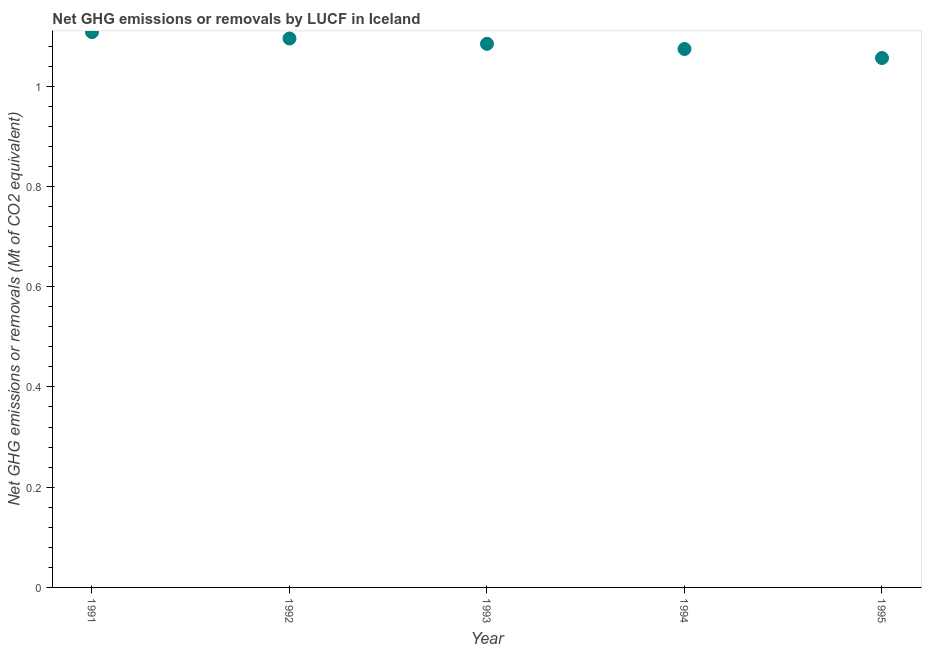What is the ghg net emissions or removals in 1992?
Provide a short and direct response. 1.1. Across all years, what is the maximum ghg net emissions or removals?
Give a very brief answer. 1.11. Across all years, what is the minimum ghg net emissions or removals?
Offer a very short reply. 1.06. What is the sum of the ghg net emissions or removals?
Provide a succinct answer. 5.42. What is the difference between the ghg net emissions or removals in 1992 and 1995?
Offer a very short reply. 0.04. What is the average ghg net emissions or removals per year?
Make the answer very short. 1.08. What is the median ghg net emissions or removals?
Make the answer very short. 1.08. In how many years, is the ghg net emissions or removals greater than 0.92 Mt?
Your response must be concise. 5. Do a majority of the years between 1992 and 1995 (inclusive) have ghg net emissions or removals greater than 0.24000000000000002 Mt?
Provide a short and direct response. Yes. What is the ratio of the ghg net emissions or removals in 1991 to that in 1993?
Keep it short and to the point. 1.02. Is the ghg net emissions or removals in 1991 less than that in 1995?
Provide a short and direct response. No. Is the difference between the ghg net emissions or removals in 1992 and 1994 greater than the difference between any two years?
Your answer should be very brief. No. What is the difference between the highest and the second highest ghg net emissions or removals?
Give a very brief answer. 0.01. Is the sum of the ghg net emissions or removals in 1991 and 1992 greater than the maximum ghg net emissions or removals across all years?
Provide a succinct answer. Yes. What is the difference between the highest and the lowest ghg net emissions or removals?
Ensure brevity in your answer.  0.05. In how many years, is the ghg net emissions or removals greater than the average ghg net emissions or removals taken over all years?
Provide a short and direct response. 3. Does the ghg net emissions or removals monotonically increase over the years?
Keep it short and to the point. No. What is the difference between two consecutive major ticks on the Y-axis?
Your answer should be very brief. 0.2. Does the graph contain grids?
Your answer should be compact. No. What is the title of the graph?
Your response must be concise. Net GHG emissions or removals by LUCF in Iceland. What is the label or title of the Y-axis?
Keep it short and to the point. Net GHG emissions or removals (Mt of CO2 equivalent). What is the Net GHG emissions or removals (Mt of CO2 equivalent) in 1991?
Ensure brevity in your answer.  1.11. What is the Net GHG emissions or removals (Mt of CO2 equivalent) in 1992?
Offer a terse response. 1.1. What is the Net GHG emissions or removals (Mt of CO2 equivalent) in 1993?
Offer a terse response. 1.08. What is the Net GHG emissions or removals (Mt of CO2 equivalent) in 1994?
Your answer should be very brief. 1.07. What is the Net GHG emissions or removals (Mt of CO2 equivalent) in 1995?
Offer a very short reply. 1.06. What is the difference between the Net GHG emissions or removals (Mt of CO2 equivalent) in 1991 and 1992?
Offer a terse response. 0.01. What is the difference between the Net GHG emissions or removals (Mt of CO2 equivalent) in 1991 and 1993?
Your response must be concise. 0.02. What is the difference between the Net GHG emissions or removals (Mt of CO2 equivalent) in 1991 and 1994?
Make the answer very short. 0.03. What is the difference between the Net GHG emissions or removals (Mt of CO2 equivalent) in 1991 and 1995?
Ensure brevity in your answer.  0.05. What is the difference between the Net GHG emissions or removals (Mt of CO2 equivalent) in 1992 and 1993?
Make the answer very short. 0.01. What is the difference between the Net GHG emissions or removals (Mt of CO2 equivalent) in 1992 and 1994?
Your response must be concise. 0.02. What is the difference between the Net GHG emissions or removals (Mt of CO2 equivalent) in 1992 and 1995?
Your response must be concise. 0.04. What is the difference between the Net GHG emissions or removals (Mt of CO2 equivalent) in 1993 and 1994?
Provide a short and direct response. 0.01. What is the difference between the Net GHG emissions or removals (Mt of CO2 equivalent) in 1993 and 1995?
Your response must be concise. 0.03. What is the difference between the Net GHG emissions or removals (Mt of CO2 equivalent) in 1994 and 1995?
Your response must be concise. 0.02. What is the ratio of the Net GHG emissions or removals (Mt of CO2 equivalent) in 1991 to that in 1992?
Keep it short and to the point. 1.01. What is the ratio of the Net GHG emissions or removals (Mt of CO2 equivalent) in 1991 to that in 1993?
Give a very brief answer. 1.02. What is the ratio of the Net GHG emissions or removals (Mt of CO2 equivalent) in 1991 to that in 1994?
Give a very brief answer. 1.03. What is the ratio of the Net GHG emissions or removals (Mt of CO2 equivalent) in 1991 to that in 1995?
Ensure brevity in your answer.  1.05. What is the ratio of the Net GHG emissions or removals (Mt of CO2 equivalent) in 1992 to that in 1993?
Provide a short and direct response. 1.01. What is the ratio of the Net GHG emissions or removals (Mt of CO2 equivalent) in 1993 to that in 1994?
Make the answer very short. 1.01. What is the ratio of the Net GHG emissions or removals (Mt of CO2 equivalent) in 1993 to that in 1995?
Give a very brief answer. 1.03. What is the ratio of the Net GHG emissions or removals (Mt of CO2 equivalent) in 1994 to that in 1995?
Provide a short and direct response. 1.02. 